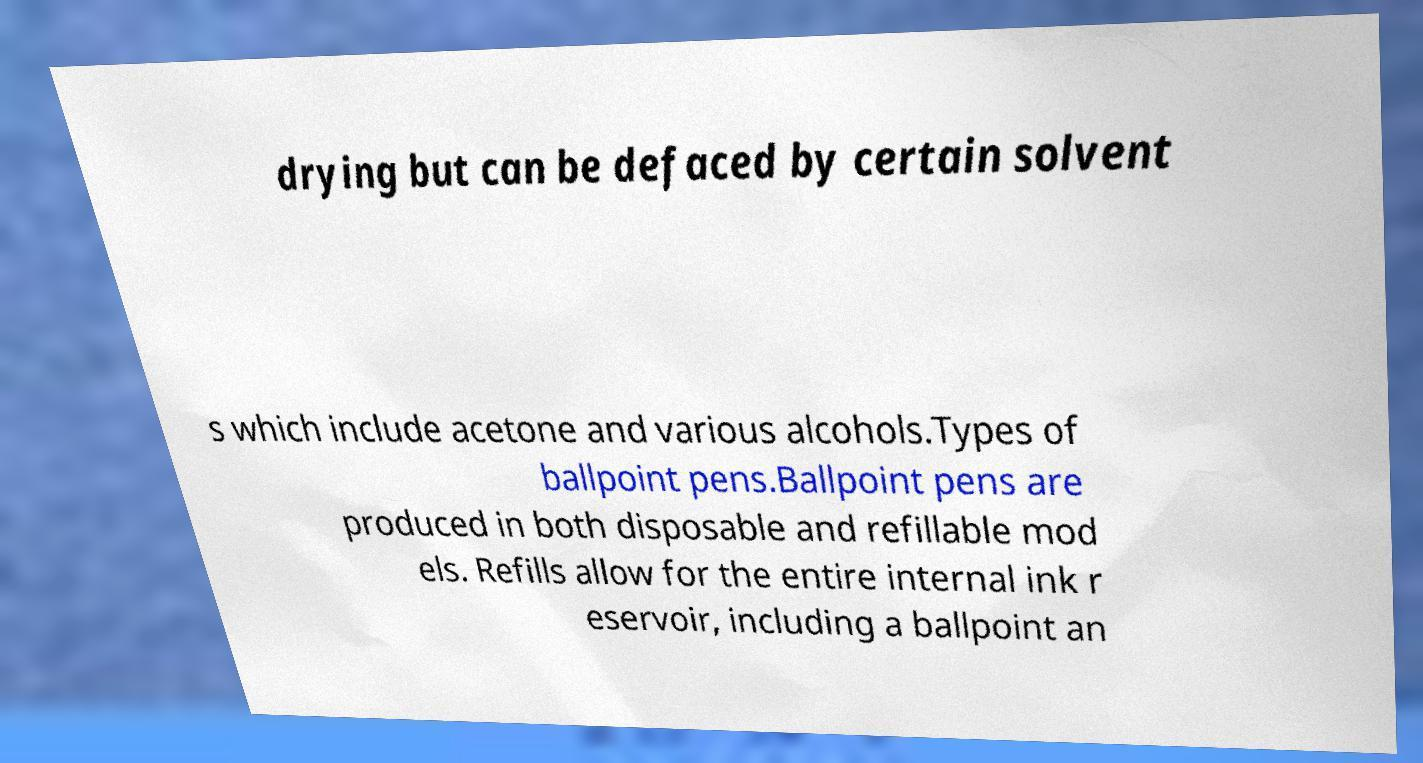I need the written content from this picture converted into text. Can you do that? drying but can be defaced by certain solvent s which include acetone and various alcohols.Types of ballpoint pens.Ballpoint pens are produced in both disposable and refillable mod els. Refills allow for the entire internal ink r eservoir, including a ballpoint an 